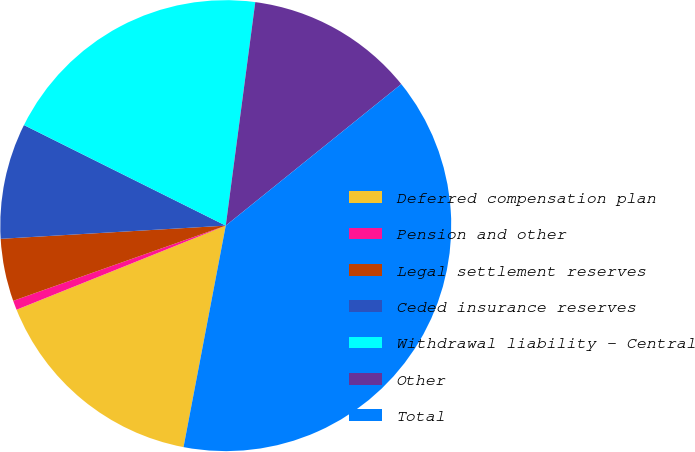Convert chart to OTSL. <chart><loc_0><loc_0><loc_500><loc_500><pie_chart><fcel>Deferred compensation plan<fcel>Pension and other<fcel>Legal settlement reserves<fcel>Ceded insurance reserves<fcel>Withdrawal liability - Central<fcel>Other<fcel>Total<nl><fcel>15.92%<fcel>0.67%<fcel>4.48%<fcel>8.29%<fcel>19.73%<fcel>12.11%<fcel>38.8%<nl></chart> 